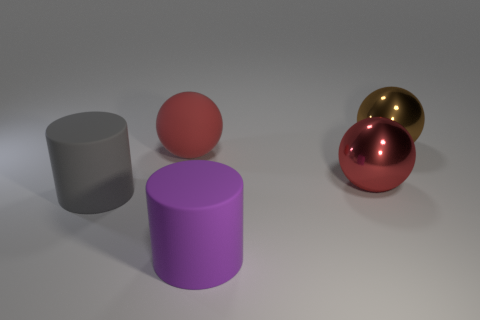If this image were part of an advertisement, what product or idea do you think it's selling? The image could be part of an advertisement for a modern home decor or a high-end designer furniture line, emphasizing simplicity, elegance, and modernity. The arrangement of shapes and the choice of colors could be emphasizing a theme of sophistication and contemporary design. 